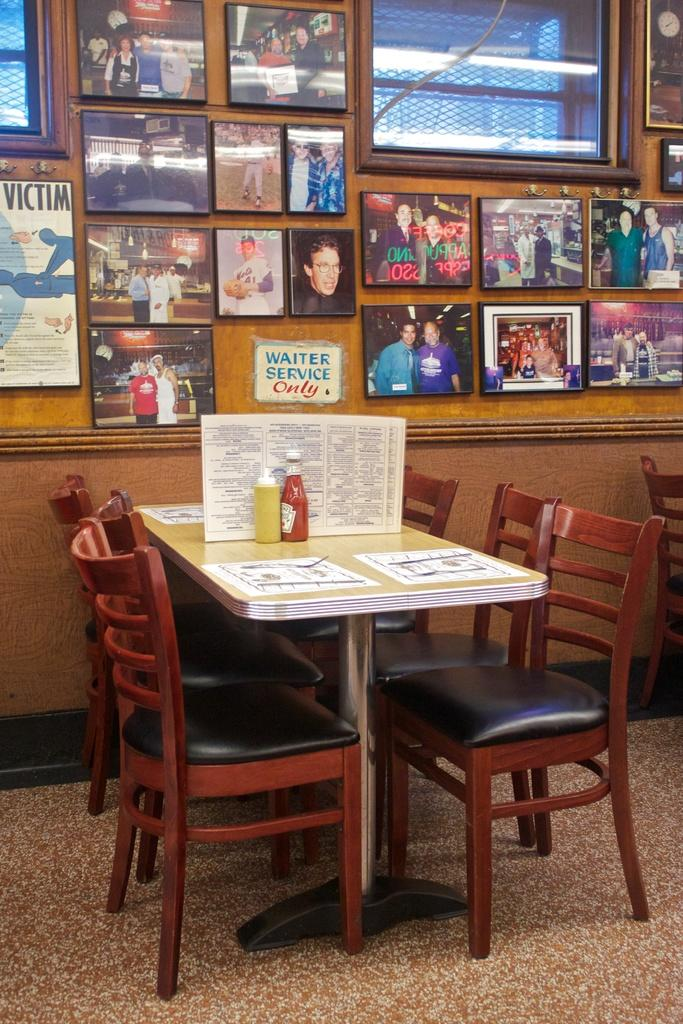What type of furniture is on the floor in the image? There is a dining table on the floor in the image. What can be found on the dining table? There are objects on the dining table. What type of seating is present in the image? There are chairs in the image. What is visible on the wall in the image? There are photo frames on the wall. What is the income of the person who owns the kite in the image? There is no kite present in the image, so it is not possible to determine the income of the person who owns it. 